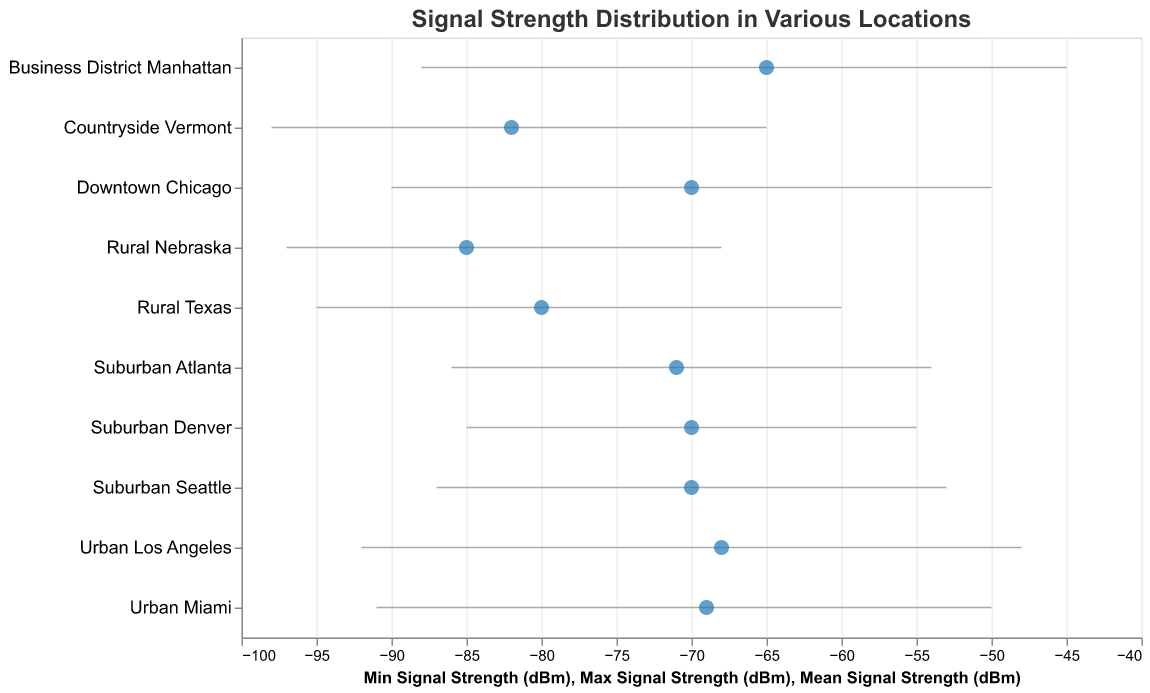What is the title of the figure? The title of the figure is located at the top and it reads "Signal Strength Distribution in Various Locations".
Answer: Signal Strength Distribution in Various Locations Which location has the highest maximum signal strength? By looking at the endpoint of the signal strength bars, Business District Manhattan has the maximum signal strength at -45 dBm.
Answer: Business District Manhattan Which location has the lowest mean signal strength? By identifying the points representing the mean signal strength, Rural Nebraska has the lowest at -85 dBm.
Answer: Rural Nebraska What is the range of signal strength in Downtown Chicago? The minimum signal strength is -90 dBm and the maximum is -50 dBm. The range is calculated as maximum minus minimum: -50 - (-90) = 40 dBm.
Answer: 40 dBm What locations have a maximum signal strength greater than -50 dBm? The visual bars showing maximum signal strength highlighted that Downtown Chicago, Urban Los Angeles, Business District Manhattan, and Urban Miami all have values greater than -50 dBm.
Answer: Downtown Chicago, Urban Los Angeles, Business District Manhattan, Urban Miami Which location has the greatest standard deviation in signal strength? By observing the provided data, Countryside Vermont has the greatest standard deviation at 11 dBm.
Answer: Countryside Vermont Calculate the difference in mean signal strength between Urban Los Angeles and Business District Manhattan. The mean signal strength for Urban Los Angeles is -68 dBm, and for Business District Manhattan, it is -65 dBm. The difference is -65 - (-68) = 3 dBm.
Answer: 3 dBm Which location has the smallest range in signal strength? The smallest range is found by identifying the shortest bar, which belongs to Suburban Denver with a range from -85 dBm to -55 dBm, giving a range of 30 dBm.
Answer: Suburban Denver What is the mean signal strength of Suburban Seattle? The mean signal strength is represented by a point and for Suburban Seattle, it is -70 dBm.
Answer: -70 dBm Compare the signal strength distribution in Rural Texas and Rural Nebraska. Which has a wider range? The range for Rural Texas is from -95 dBm to -60 dBm (range is 35 dBm). The range for Rural Nebraska is from -97 dBm to -68 dBm (range is 29 dBm). Therefore, Rural Texas has a wider range.
Answer: Rural Texas 